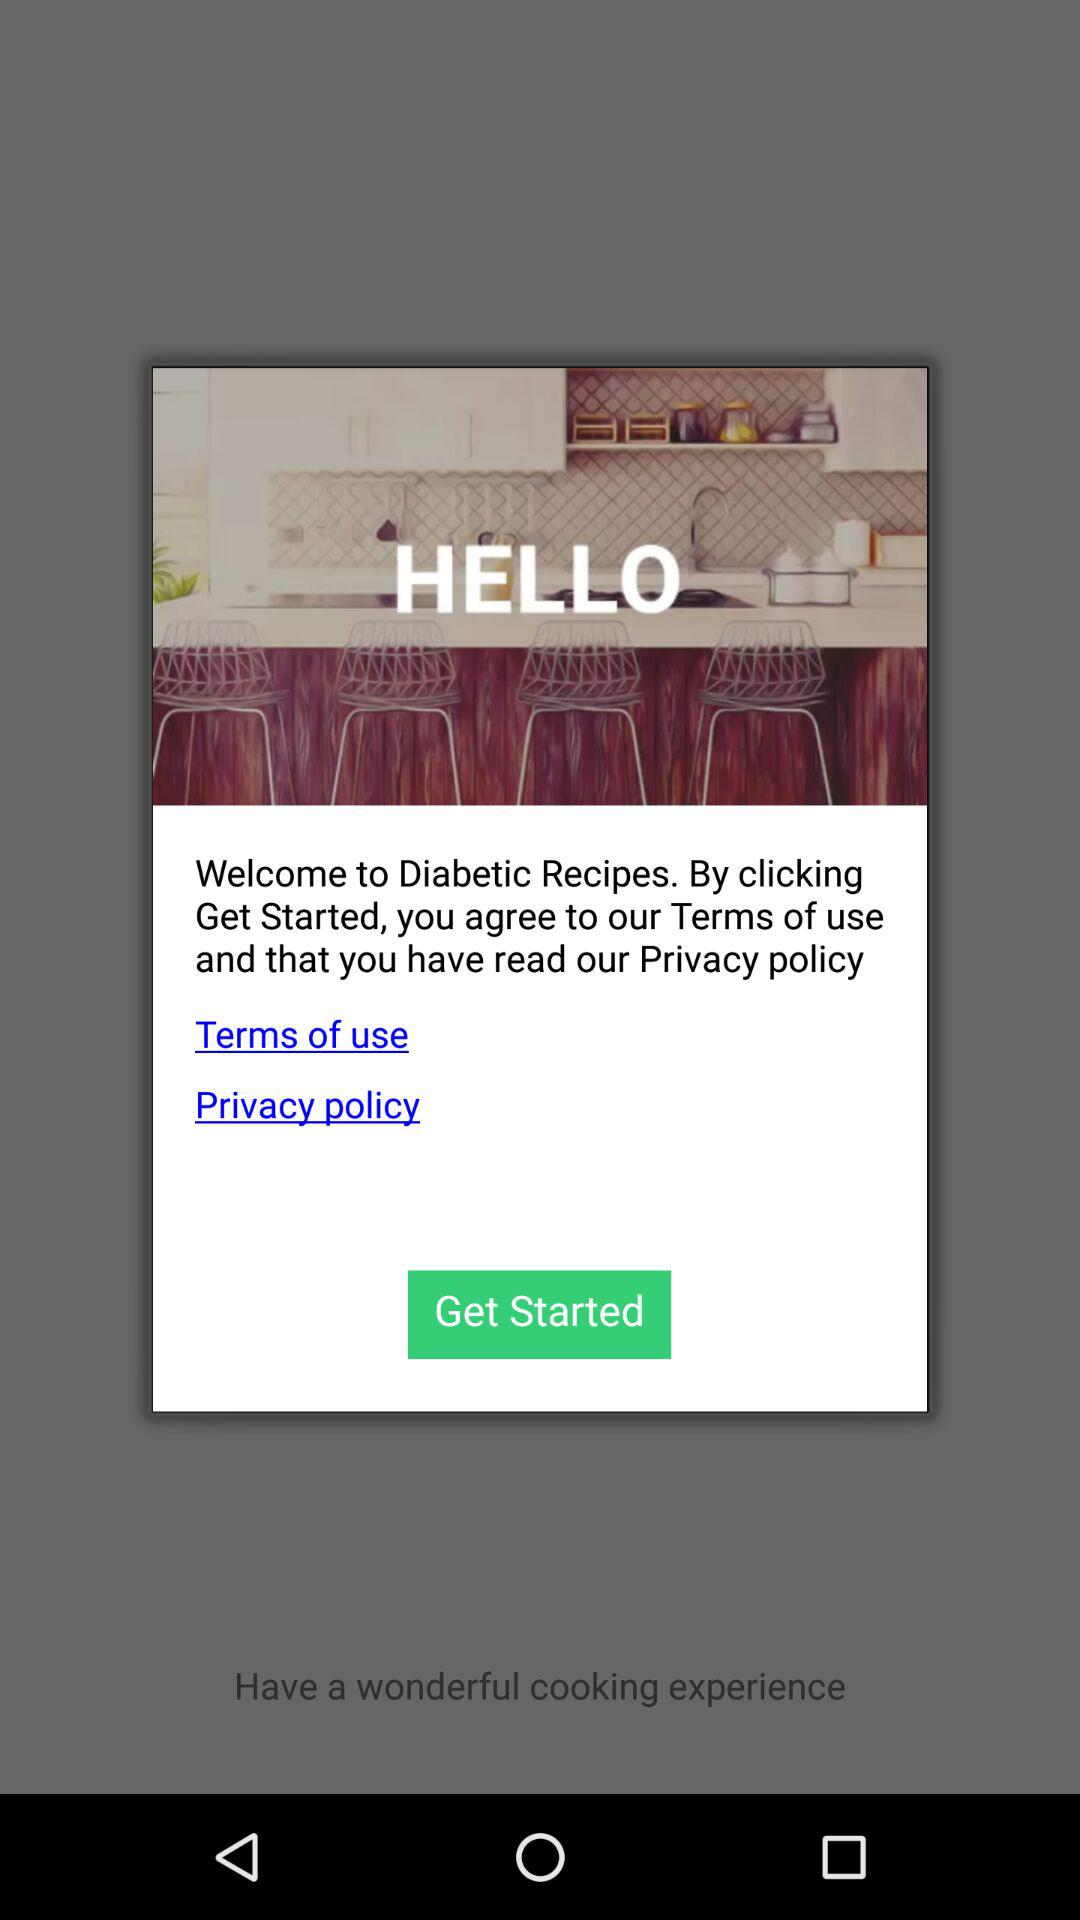What is the name of the application? The name of the application is "HELLO". 